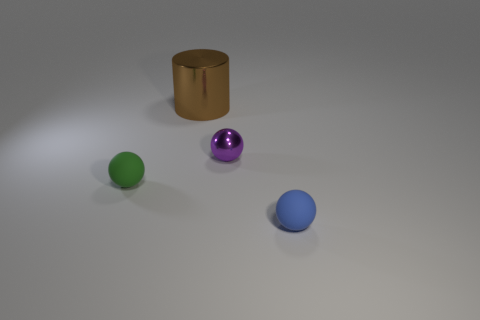Add 2 tiny blue balls. How many objects exist? 6 Subtract all balls. How many objects are left? 1 Add 3 tiny things. How many tiny things are left? 6 Add 4 tiny purple objects. How many tiny purple objects exist? 5 Subtract 0 green cylinders. How many objects are left? 4 Subtract all purple metallic balls. Subtract all tiny brown cubes. How many objects are left? 3 